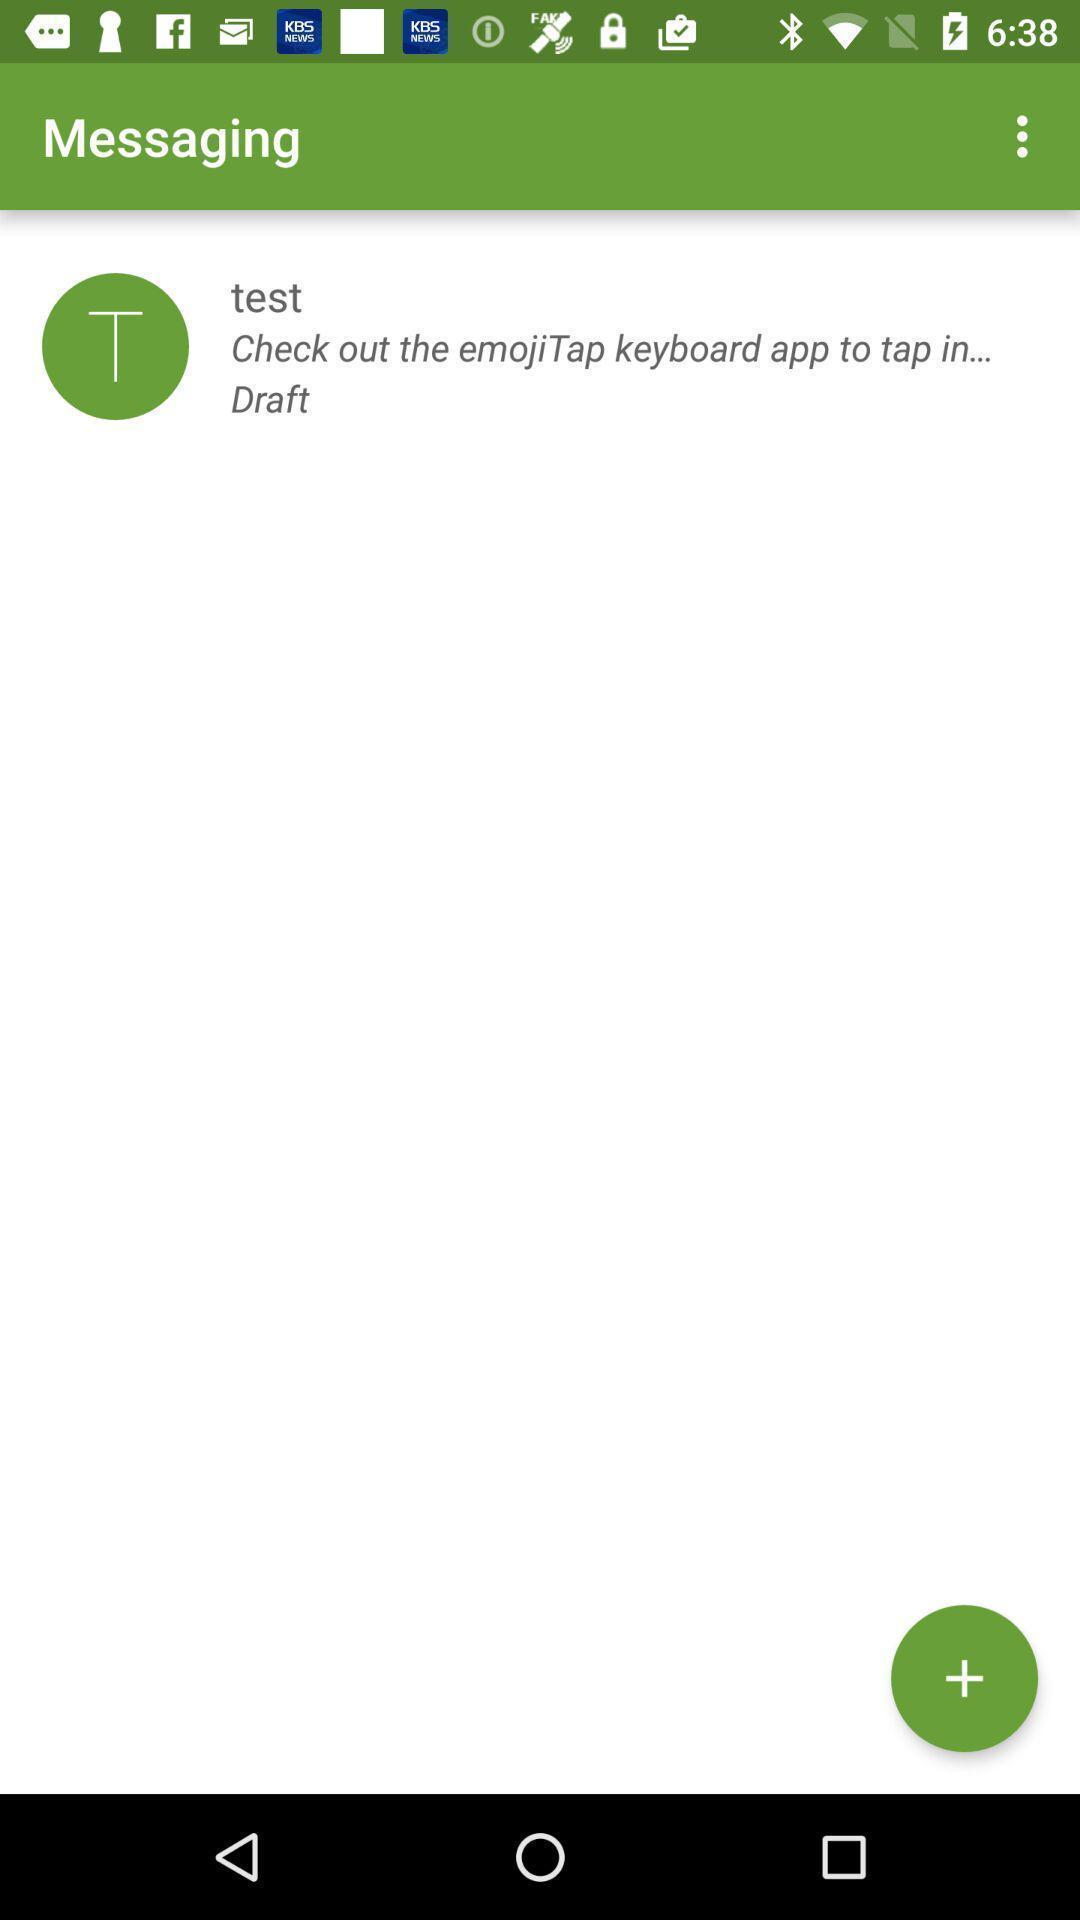Describe the visual elements of this screenshot. Page for the messaging in the social app. 